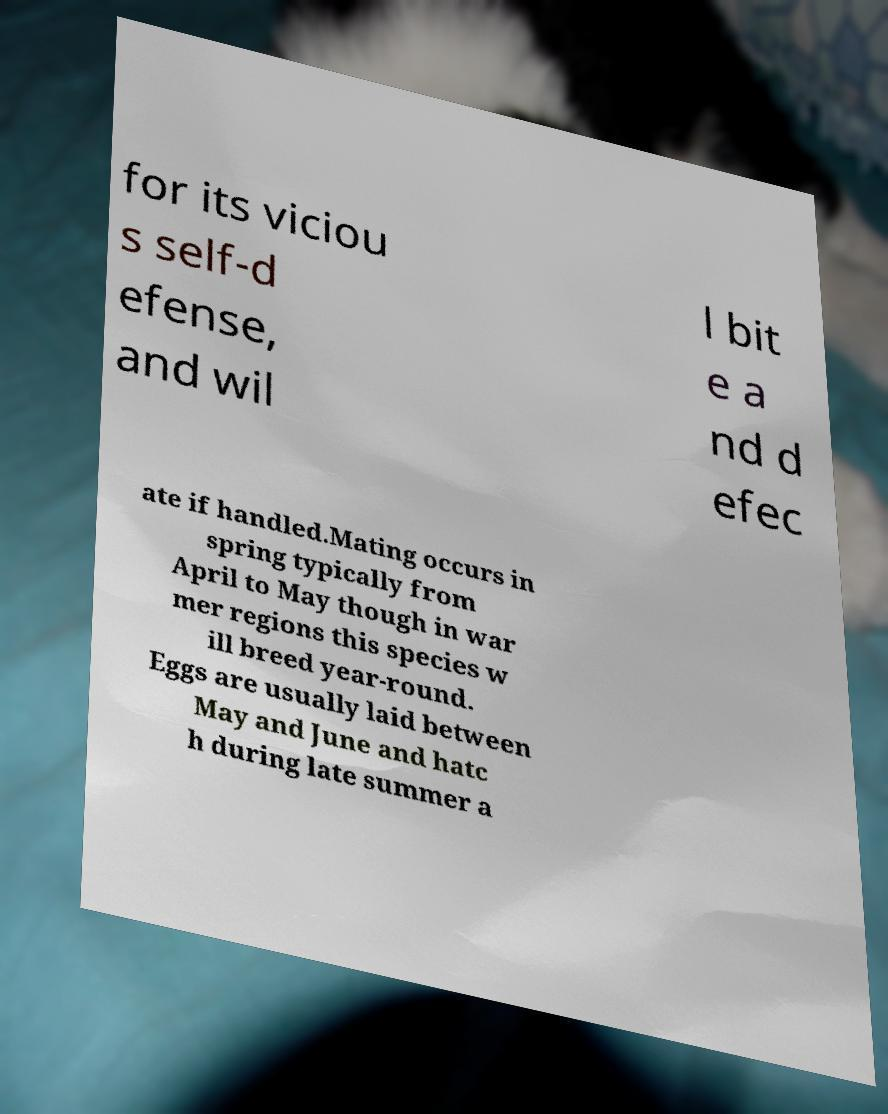What messages or text are displayed in this image? I need them in a readable, typed format. for its viciou s self-d efense, and wil l bit e a nd d efec ate if handled.Mating occurs in spring typically from April to May though in war mer regions this species w ill breed year-round. Eggs are usually laid between May and June and hatc h during late summer a 